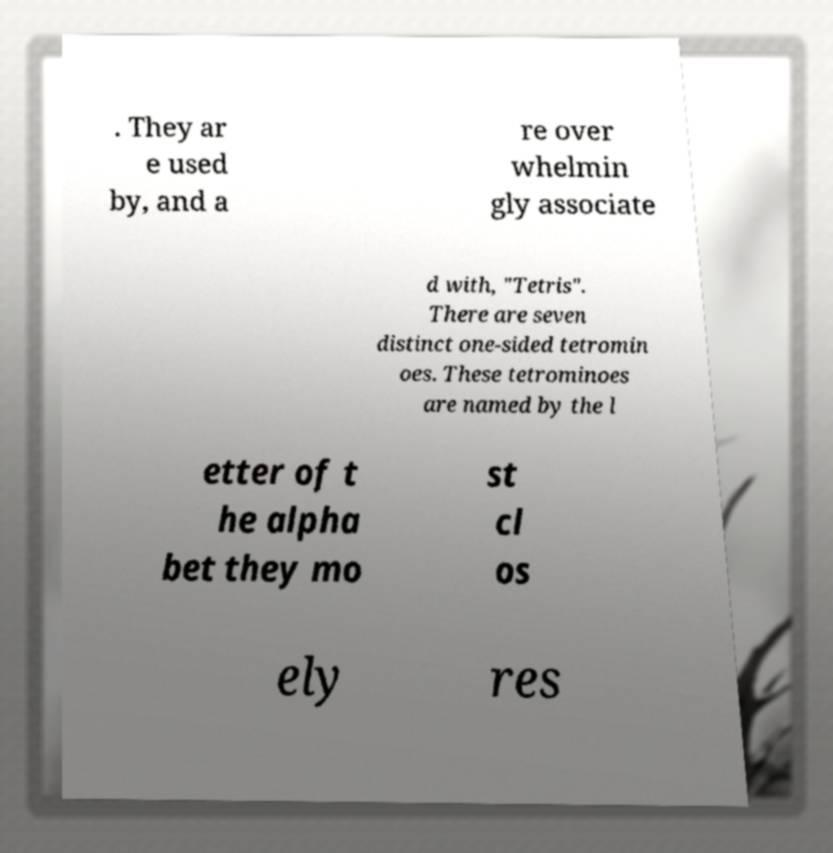For documentation purposes, I need the text within this image transcribed. Could you provide that? . They ar e used by, and a re over whelmin gly associate d with, "Tetris". There are seven distinct one-sided tetromin oes. These tetrominoes are named by the l etter of t he alpha bet they mo st cl os ely res 